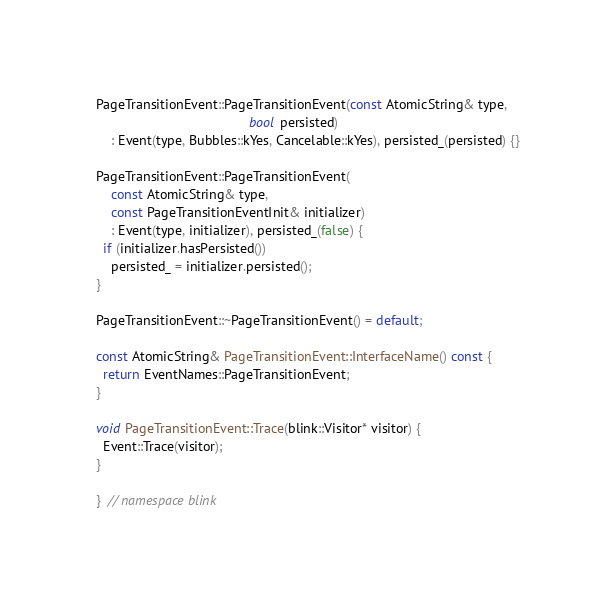Convert code to text. <code><loc_0><loc_0><loc_500><loc_500><_C++_>
PageTransitionEvent::PageTransitionEvent(const AtomicString& type,
                                         bool persisted)
    : Event(type, Bubbles::kYes, Cancelable::kYes), persisted_(persisted) {}

PageTransitionEvent::PageTransitionEvent(
    const AtomicString& type,
    const PageTransitionEventInit& initializer)
    : Event(type, initializer), persisted_(false) {
  if (initializer.hasPersisted())
    persisted_ = initializer.persisted();
}

PageTransitionEvent::~PageTransitionEvent() = default;

const AtomicString& PageTransitionEvent::InterfaceName() const {
  return EventNames::PageTransitionEvent;
}

void PageTransitionEvent::Trace(blink::Visitor* visitor) {
  Event::Trace(visitor);
}

}  // namespace blink
</code> 